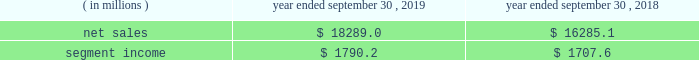Containerboard , kraft papers and saturating kraft .
Kapstone also owns victory packaging , a packaging solutions distribution company with facilities in the u.s. , canada and mexico .
We have included the financial results of kapstone in our corrugated packaging segment since the date of the acquisition .
On september 4 , 2018 , we completed the acquisition ( the 201cschl fcter acquisition 201d ) of schl fcter print pharma packaging ( 201cschl fcter 201d ) .
Schl fcter is a leading provider of differentiated paper and packaging solutions and a german-based supplier of a full range of leaflets and booklets .
The schl fcter acquisition allowed us to further enhance our pharmaceutical and automotive platform and expand our geographical footprint in europe to better serve our customers .
We have included the financial results of the acquired operations in our consumer packaging segment since the date of the acquisition .
On january 5 , 2018 , we completed the acquisition ( the 201cplymouth packaging acquisition 201d ) of substantially all of the assets of plymouth packaging , inc .
( 201cplymouth 201d ) .
The assets we acquired included plymouth 2019s 201cbox on demand 201d systems , which are manufactured by panotec , an italian manufacturer of packaging machines .
The addition of the box on demand systems enhanced our platform , differentiation and innovation .
These systems , which are located on customers 2019 sites under multi-year exclusive agreements , use fanfold corrugated to produce custom , on-demand corrugated packaging that is accurately sized for any product type according to the customer 2019s specifications .
Fanfold corrugated is continuous corrugated board , folded periodically to form an accordion-like stack of corrugated material .
As part of the transaction , westrock acquired plymouth 2019s equity interest in panotec and plymouth 2019s exclusive right from panotec to distribute panotec 2019s equipment in the u.s .
And canada .
We have fully integrated the approximately 60000 tons of containerboard used by plymouth annually .
We have included the financial results of plymouth in our corrugated packaging segment since the date of the acquisition .
See 201cnote 3 .
Acquisitions and investment 201d of the notes to consolidated financial statements for additional information .
See also item 1a .
201crisk factors 2014 we may be unsuccessful in making and integrating mergers , acquisitions and investments , and completing divestitures 201d .
Business .
In fiscal 2019 , we continued to pursue our strategy of offering differentiated paper and packaging solutions that help our customers win .
We successfully executed this strategy in fiscal 2019 in a rapidly changing cost and price environment .
Net sales of $ 18289.0 million for fiscal 2019 increased $ 2003.9 million , or 12.3% ( 12.3 % ) , compared to fiscal 2018 .
The increase was primarily due to the kapstone acquisition and higher selling price/mix in our corrugated packaging and consumer packaging segments .
These increases were partially offset by the absence of recycling net sales in fiscal 2019 as a result of conducting the operations primarily as a procurement function beginning in the first quarter of fiscal 2019 , lower volumes , unfavorable foreign currency impacts across our segments compared to the prior year and decreased land and development net sales .
Segment income increased $ 82.6 million in fiscal 2019 compared to fiscal 2018 , primarily due to increased corrugated packaging segment income that was partially offset by lower consumer packaging and land and development segment income .
The impact of the contribution from the acquired kapstone operations , higher selling price/mix across our segments and productivity improvements was largely offset by lower volumes across our segments , economic downtime , cost inflation , increased maintenance and scheduled strategic outage expense ( including projects at our mahrt , al and covington , va mills ) and lower land and development segment income due to the wind-down of sales .
With respect to segment income , we experienced higher levels of cost inflation in both our corrugated packaging and consumer packaging segments during fiscal 2019 as compared to fiscal 2018 that were partially offset by recovered fiber deflation .
The primary inflationary items were virgin fiber , freight , energy and wage and other costs .
We generated $ 2310.2 million of net cash provided by operating activities in fiscal 2019 , compared to $ 1931.2 million in fiscal 2018 .
We remained committed to our disciplined capital allocation strategy during fiscal .
What was the average net sales between 2018 and 2019? 
Computations: (((18289.0 + 16285.1) + 2) / 2)
Answer: 17288.05. 